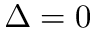Convert formula to latex. <formula><loc_0><loc_0><loc_500><loc_500>\Delta = 0</formula> 